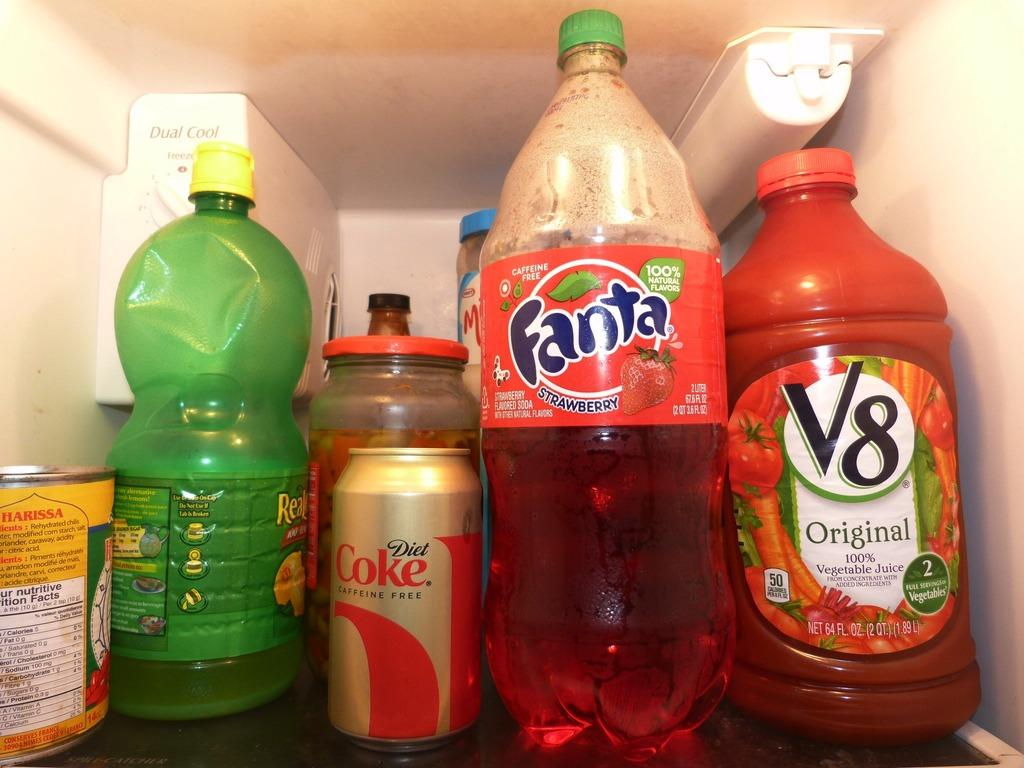<image>
Describe the image concisely. A bottle of Fanta i the fridge next to a V8 bottle. 